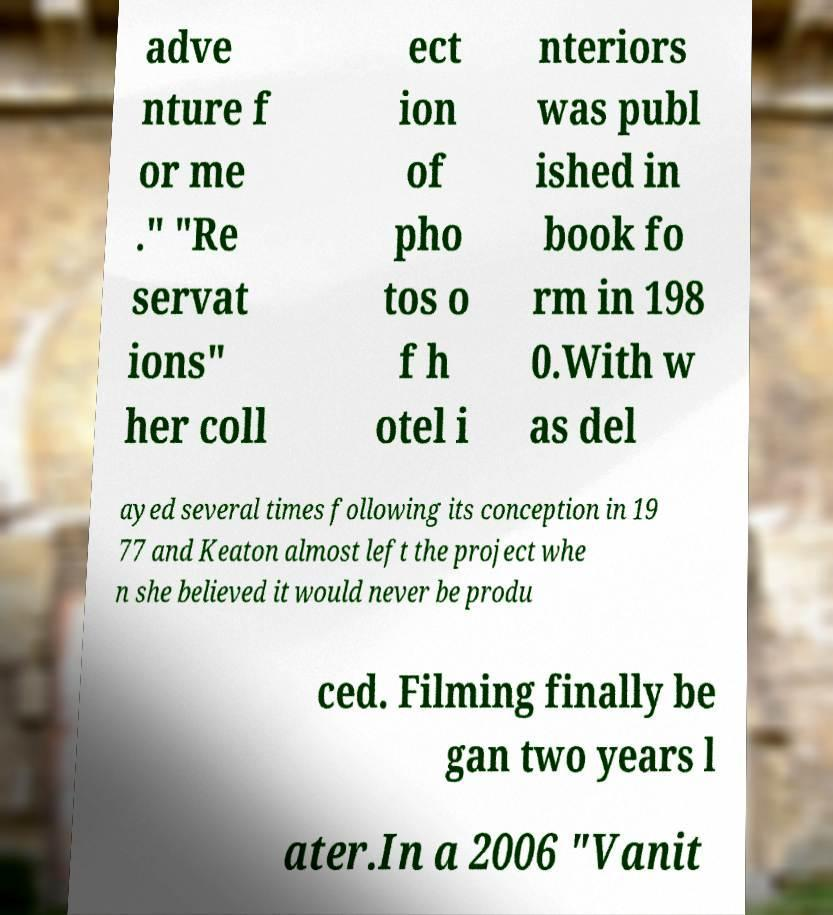Can you read and provide the text displayed in the image?This photo seems to have some interesting text. Can you extract and type it out for me? adve nture f or me ." "Re servat ions" her coll ect ion of pho tos o f h otel i nteriors was publ ished in book fo rm in 198 0.With w as del ayed several times following its conception in 19 77 and Keaton almost left the project whe n she believed it would never be produ ced. Filming finally be gan two years l ater.In a 2006 "Vanit 